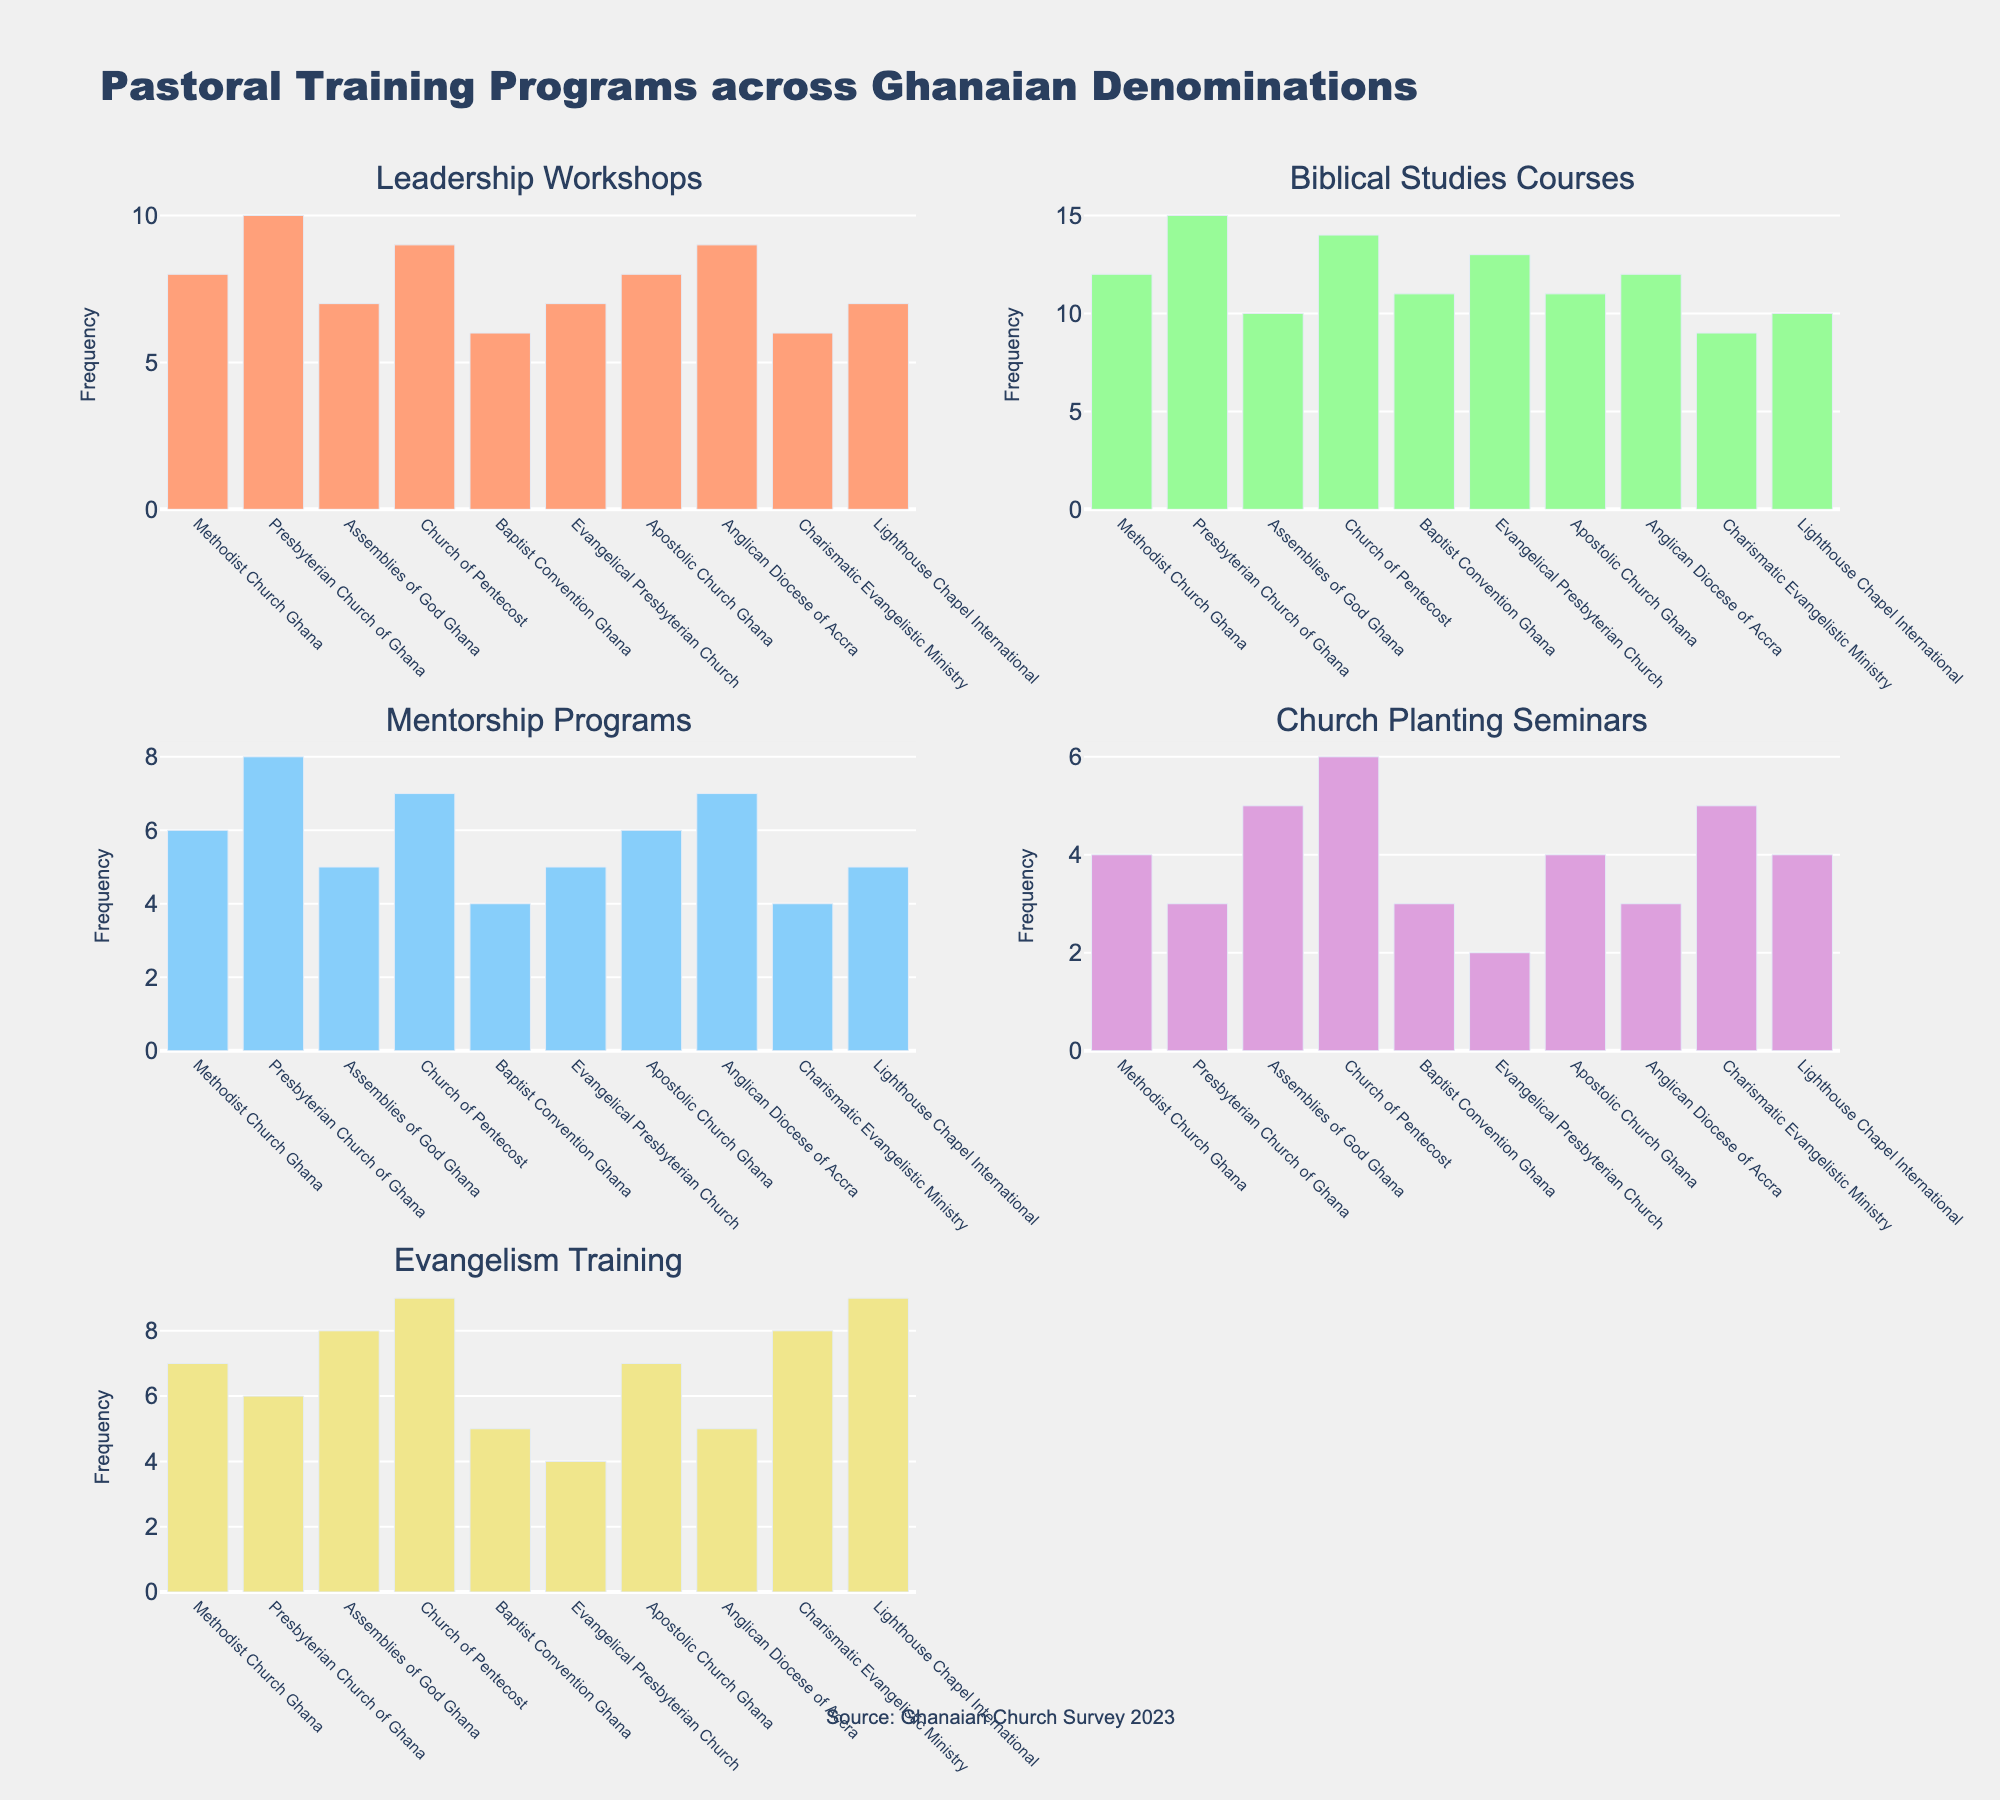What's the overall title of the figure? The overall title is located at the top center of the figure. It is "Pastoral Training Programs across Ghanaian Denominations".
Answer: Pastoral Training Programs across Ghanaian Denominations Which denomination offers the highest number of Leadership Workshops? Look at the subplot for Leadership Workshops. The tallest bar represents the Presbyterian Church of Ghana.
Answer: Presbyterian Church of Ghana How many Mentorship Programs are offered by Baptists? In the subplot for Mentorship Programs, find the bar representing the Baptist Convention Ghana. The frequency is 4.
Answer: 4 What is the total number of Evangelism Training programs offered across all denominations? Add the frequencies of Evangelism Training from each denomination: 7 + 6 + 8 + 9 + 5 + 4 + 7 + 5 + 8 + 9. The total is 68.
Answer: 68 Which type of training is offered the most by the Church of Pentecost? Check the various subplots for bars associated with the Church of Pentecost. The highest frequency is for Evangelism Training (9).
Answer: Evangelism Training What is the average number of Church Planting Seminars offered across all denominations? Add the frequencies of Church Planting Seminars and divide by the number of denominations: (4 + 3 + 5 + 6 + 3 + 2 + 4 + 3 + 5 + 4)/10. The average is 3.9.
Answer: 3.9 Which denomination offers fewer than 5 Biblical Studies Courses? Check the Biblical Studies Courses subplot and identify denominations with bars below 5. None of the denominations offer fewer than 5 courses in this category.
Answer: None Is the frequency of Church Planting Seminars higher than Leadership Workshops for the Assemblies of God Ghana? Compare the bar heights for Church Planting Seminars and Leadership Workshops for the Assemblies of God Ghana. Leadership Workshops (7) is greater than Church Planting Seminars (5).
Answer: No Which denominations offer the same number of Evangelism Training programs? Identify denominations with equal bar heights for Evangelism Training. The Church of Pentecost and Lighthouse Chapel International both offer 9 programs.
Answer: Church of Pentecost, Lighthouse Chapel International Which training type has the most consistent frequency across all denominations? Look for the subplot with the smallest variance in bar heights. Biblical Studies Courses appear the most consistent across denominations.
Answer: Biblical Studies Courses 